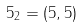Convert formula to latex. <formula><loc_0><loc_0><loc_500><loc_500>5 _ { 2 } = ( 5 , 5 )</formula> 